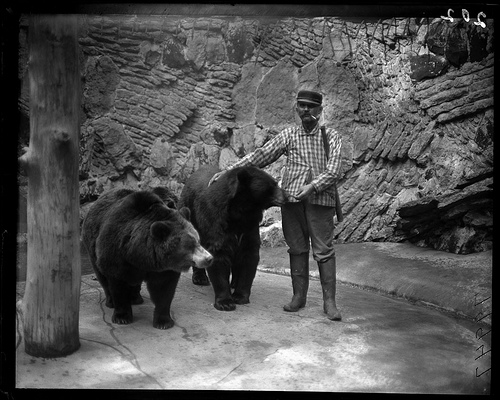What period does this photograph appear to be from? Given the monochrome quality and the style of clothing worn by the person in the image, it appears to be from the early 20th century, possibly between the 1920s and 1940s. 